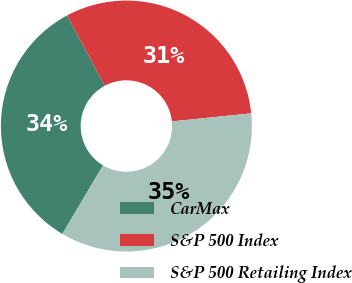<chart> <loc_0><loc_0><loc_500><loc_500><pie_chart><fcel>CarMax<fcel>S&P 500 Index<fcel>S&P 500 Retailing Index<nl><fcel>33.64%<fcel>31.22%<fcel>35.14%<nl></chart> 